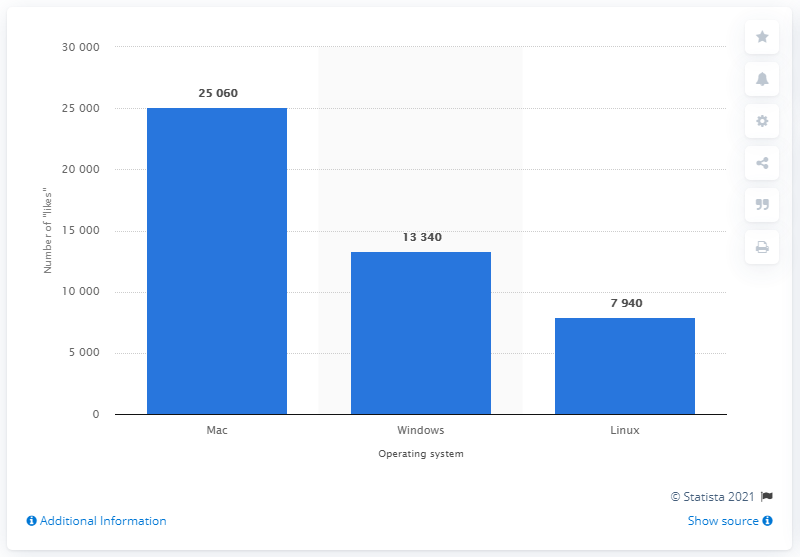Draw attention to some important aspects in this diagram. In July 2011, Linux received a total of 7,940 likes from U.S. college students. 